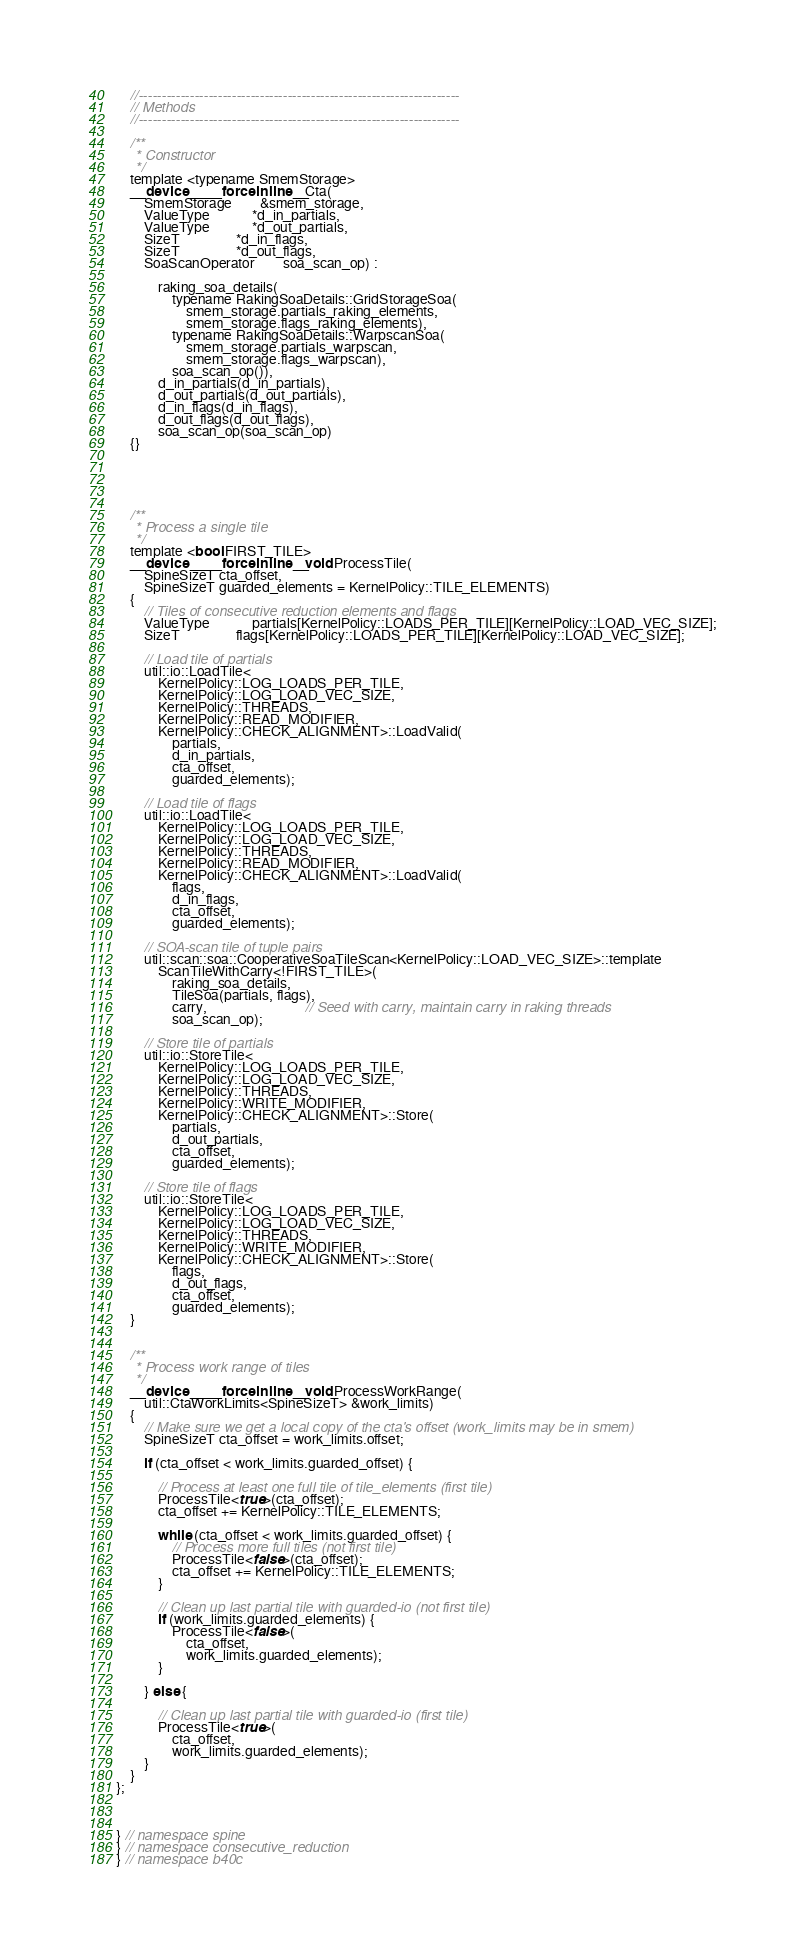Convert code to text. <code><loc_0><loc_0><loc_500><loc_500><_Cuda_>
	//---------------------------------------------------------------------
	// Methods
	//---------------------------------------------------------------------

	/**
	 * Constructor
	 */
	template <typename SmemStorage>
	__device__ __forceinline__ Cta(
		SmemStorage 		&smem_storage,
		ValueType 			*d_in_partials,
		ValueType 			*d_out_partials,
		SizeT 				*d_in_flags,
		SizeT				*d_out_flags,
		SoaScanOperator		soa_scan_op) :

			raking_soa_details(
				typename RakingSoaDetails::GridStorageSoa(
					smem_storage.partials_raking_elements,
					smem_storage.flags_raking_elements),
				typename RakingSoaDetails::WarpscanSoa(
					smem_storage.partials_warpscan,
					smem_storage.flags_warpscan),
				soa_scan_op()),
			d_in_partials(d_in_partials),
			d_out_partials(d_out_partials),
			d_in_flags(d_in_flags),
			d_out_flags(d_out_flags),
			soa_scan_op(soa_scan_op)
	{}





	/**
	 * Process a single tile
	 */
	template <bool FIRST_TILE>
	__device__ __forceinline__ void ProcessTile(
		SpineSizeT cta_offset,
		SpineSizeT guarded_elements = KernelPolicy::TILE_ELEMENTS)
	{
		// Tiles of consecutive reduction elements and flags
		ValueType			partials[KernelPolicy::LOADS_PER_TILE][KernelPolicy::LOAD_VEC_SIZE];
		SizeT				flags[KernelPolicy::LOADS_PER_TILE][KernelPolicy::LOAD_VEC_SIZE];

		// Load tile of partials
		util::io::LoadTile<
			KernelPolicy::LOG_LOADS_PER_TILE,
			KernelPolicy::LOG_LOAD_VEC_SIZE,
			KernelPolicy::THREADS,
			KernelPolicy::READ_MODIFIER,
			KernelPolicy::CHECK_ALIGNMENT>::LoadValid(
				partials,
				d_in_partials,
				cta_offset,
				guarded_elements);

		// Load tile of flags
		util::io::LoadTile<
			KernelPolicy::LOG_LOADS_PER_TILE,
			KernelPolicy::LOG_LOAD_VEC_SIZE,
			KernelPolicy::THREADS,
			KernelPolicy::READ_MODIFIER,
			KernelPolicy::CHECK_ALIGNMENT>::LoadValid(
				flags,
				d_in_flags,
				cta_offset,
				guarded_elements);

		// SOA-scan tile of tuple pairs
		util::scan::soa::CooperativeSoaTileScan<KernelPolicy::LOAD_VEC_SIZE>::template
			ScanTileWithCarry<!FIRST_TILE>(
				raking_soa_details,
				TileSoa(partials, flags),
				carry,							// Seed with carry, maintain carry in raking threads
				soa_scan_op);

		// Store tile of partials
		util::io::StoreTile<
			KernelPolicy::LOG_LOADS_PER_TILE,
			KernelPolicy::LOG_LOAD_VEC_SIZE,
			KernelPolicy::THREADS,
			KernelPolicy::WRITE_MODIFIER,
			KernelPolicy::CHECK_ALIGNMENT>::Store(
				partials,
				d_out_partials,
				cta_offset,
				guarded_elements);

		// Store tile of flags
		util::io::StoreTile<
			KernelPolicy::LOG_LOADS_PER_TILE,
			KernelPolicy::LOG_LOAD_VEC_SIZE,
			KernelPolicy::THREADS,
			KernelPolicy::WRITE_MODIFIER,
			KernelPolicy::CHECK_ALIGNMENT>::Store(
				flags,
				d_out_flags,
				cta_offset,
				guarded_elements);
	}


	/**
	 * Process work range of tiles
	 */
	__device__ __forceinline__ void ProcessWorkRange(
		util::CtaWorkLimits<SpineSizeT> &work_limits)
	{
		// Make sure we get a local copy of the cta's offset (work_limits may be in smem)
		SpineSizeT cta_offset = work_limits.offset;

		if (cta_offset < work_limits.guarded_offset) {

			// Process at least one full tile of tile_elements (first tile)
			ProcessTile<true>(cta_offset);
			cta_offset += KernelPolicy::TILE_ELEMENTS;

			while (cta_offset < work_limits.guarded_offset) {
				// Process more full tiles (not first tile)
				ProcessTile<false>(cta_offset);
				cta_offset += KernelPolicy::TILE_ELEMENTS;
			}

			// Clean up last partial tile with guarded-io (not first tile)
			if (work_limits.guarded_elements) {
				ProcessTile<false>(
					cta_offset,
					work_limits.guarded_elements);
			}

		} else {

			// Clean up last partial tile with guarded-io (first tile)
			ProcessTile<true>(
				cta_offset,
				work_limits.guarded_elements);
		}
	}
};



} // namespace spine
} // namespace consecutive_reduction
} // namespace b40c

</code> 